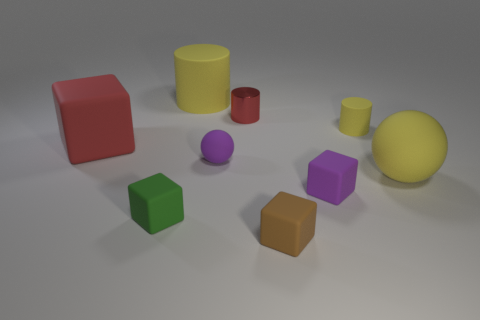Can you describe the lighting in the scene? The lighting in the scene appears to be soft and diffuse, likely from an overhead source. It casts gentle shadows directly underneath the objects, indicating the light is not particularly harsh or direct. 